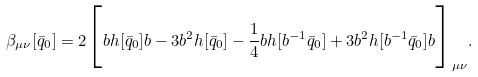<formula> <loc_0><loc_0><loc_500><loc_500>\beta _ { \mu \nu } [ { \bar { q } } _ { 0 } ] = 2 \Big { [ } b h [ { \bar { q } } _ { 0 } ] b - 3 b ^ { 2 } h [ { \bar { q } } _ { 0 } ] - \frac { 1 } { 4 } b { h } [ b ^ { - 1 } { \bar { q } } _ { 0 } ] + 3 b ^ { 2 } { h } [ b ^ { - 1 } { \bar { q } } _ { 0 } ] b \Big { ] } _ { \mu \nu } .</formula> 